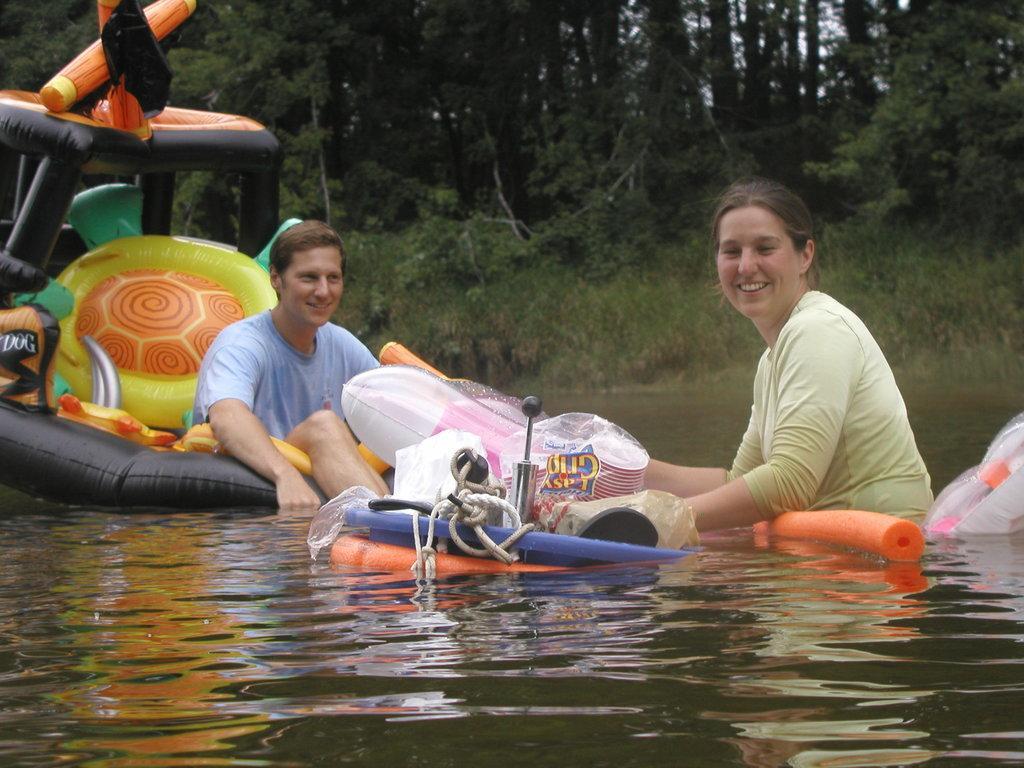Please provide a concise description of this image. In this picture we can see an inflatable boat on water, here we can see a man and a woman and they are smiling and in the background we can see trees. 